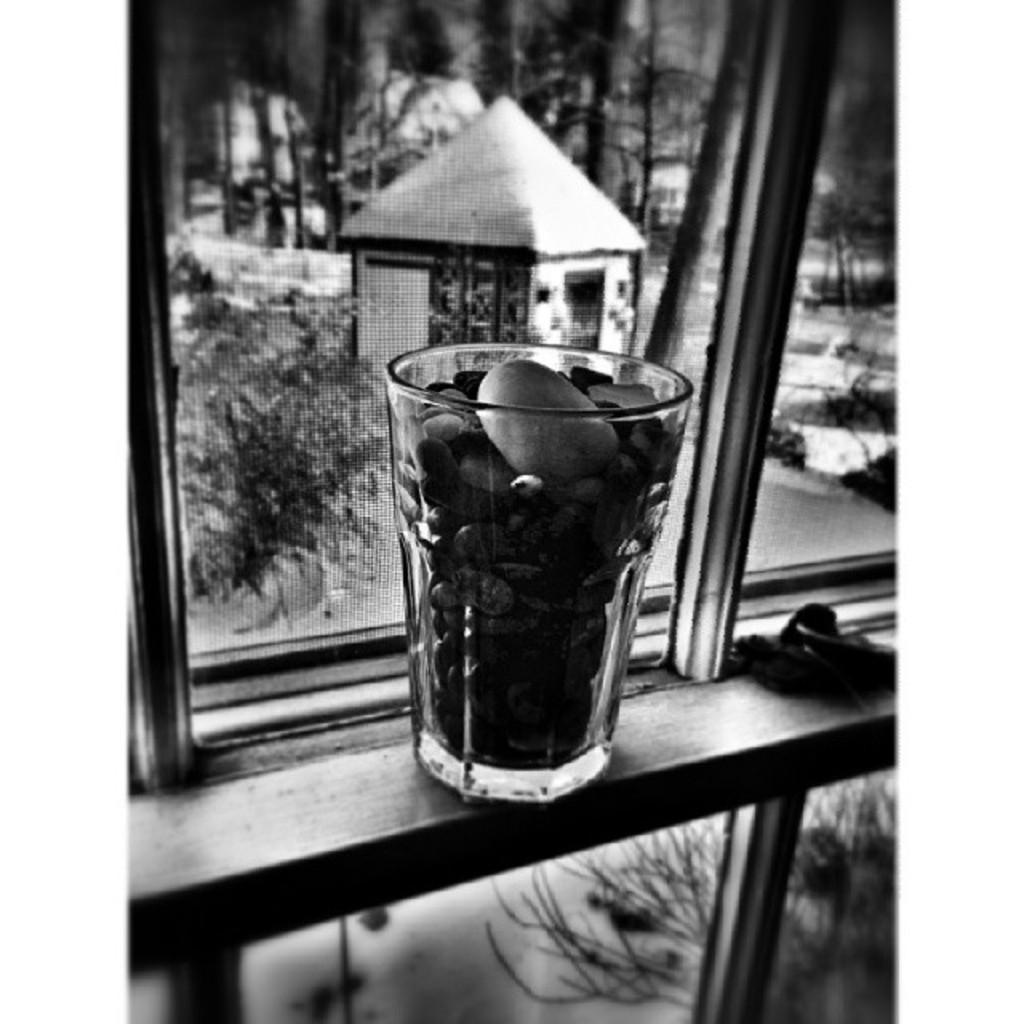Could you give a brief overview of what you see in this image? It is the black and white image in which there is a glass kept near the window. In the glass there are stones. Through the window we can see that there is a small hut and plants beside it. 